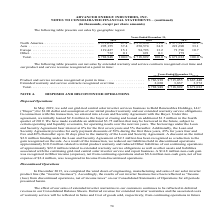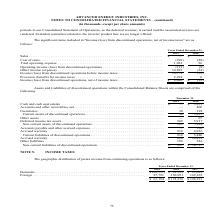According to Advanced Energy's financial document, When did the winding down of engineering, manufacturing and sales of solar inverter product line occur? According to the financial document, December 2015. The relevant text states: "In December 2015, we completed the wind down of engineering, manufacturing and sales of our solar inverter product l..." Also, What was the Cash and cash equivalents in 2018? According to the financial document, $ 5,251 (in thousands). The relevant text states: "Cash and cash equivalents . $ — $ 5,251..." Also, What were the Inventories in 2019? According to the financial document, 30 (in thousands). The relevant text states: "and other receivables, net . — 406 Inventories . 30 198 Current assets of discontinued operations . 30 5,855..." Also, can you calculate: What was the change in current assets of discontinued operations between 2018 and 2019? Based on the calculation: 30-5,855, the result is -5825 (in thousands). This is based on the information: "and other receivables, net . — 406 Inventories . 30 198 Current assets of discontinued operations . 30 5,855 98 Current assets of discontinued operations . 30 5,855..." The key data points involved are: 30, 5,855. Also, can you calculate: What was the change in Accrued warranty of Accounts payable and other accrued expenses between 2018 and 2019? Based on the calculation: 914-4,936, the result is -4022 (in thousands). This is based on the information: "Accrued warranty . 914 4,936 Current liabilities of discontinued operations . 914 5,286 Accrued warranty . 914 4,936 Current liabilities of discontinued operations . 914 5,286..." The key data points involved are: 4,936, 914. Also, can you calculate: What is the percentage change in Non-current liabilities of discontinued operations between 2018 and 2019? To answer this question, I need to perform calculations using the financial data. The calculation is: ($887-$10,715)/$10,715, which equals -91.72 (percentage). This is based on the information: "liabilities of discontinued operations . $ 887 $ 10,715 urrent liabilities of discontinued operations . $ 887 $ 10,715..." The key data points involved are: 10,715, 887. 